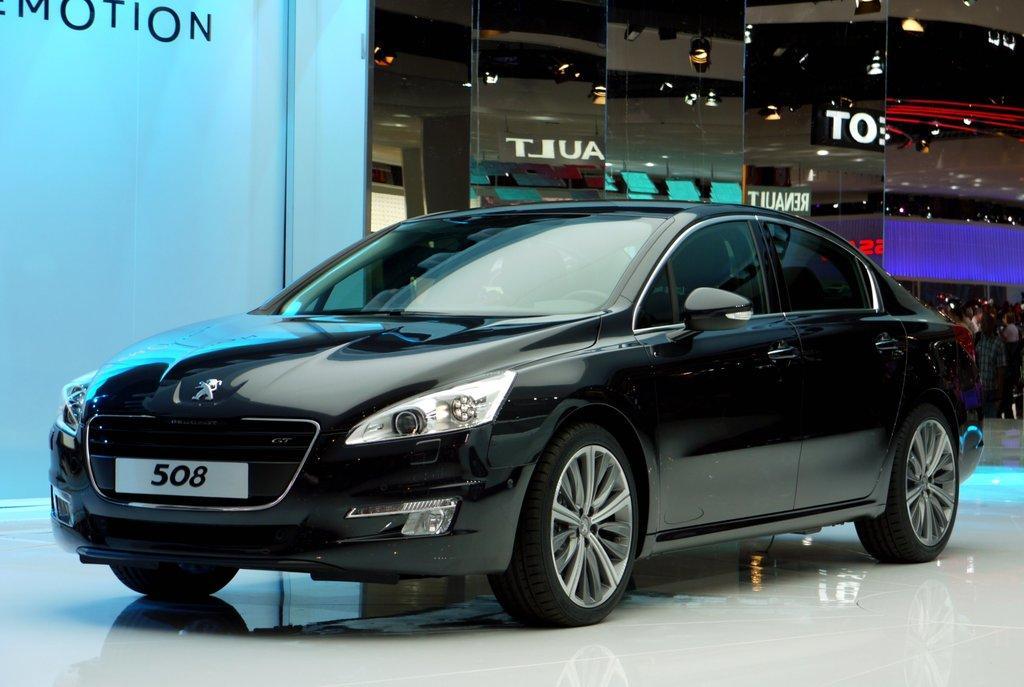Please provide a concise description of this image. In this picture we can see a black car and behind the car it is looking like a board, a group of people standing and glasses. On the glasses we can see the reflection of lights and name boards. 